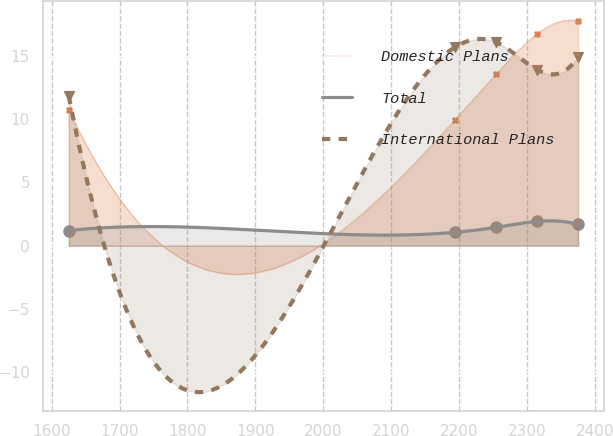Convert chart. <chart><loc_0><loc_0><loc_500><loc_500><line_chart><ecel><fcel>Domestic Plans<fcel>Total<fcel>International Plans<nl><fcel>1625.03<fcel>10.73<fcel>1.2<fcel>11.83<nl><fcel>2193.78<fcel>9.95<fcel>1.06<fcel>15.66<nl><fcel>2254.3<fcel>13.55<fcel>1.45<fcel>16.07<nl><fcel>2314.82<fcel>16.73<fcel>1.92<fcel>13.9<nl><fcel>2375.34<fcel>17.75<fcel>1.68<fcel>14.92<nl></chart> 